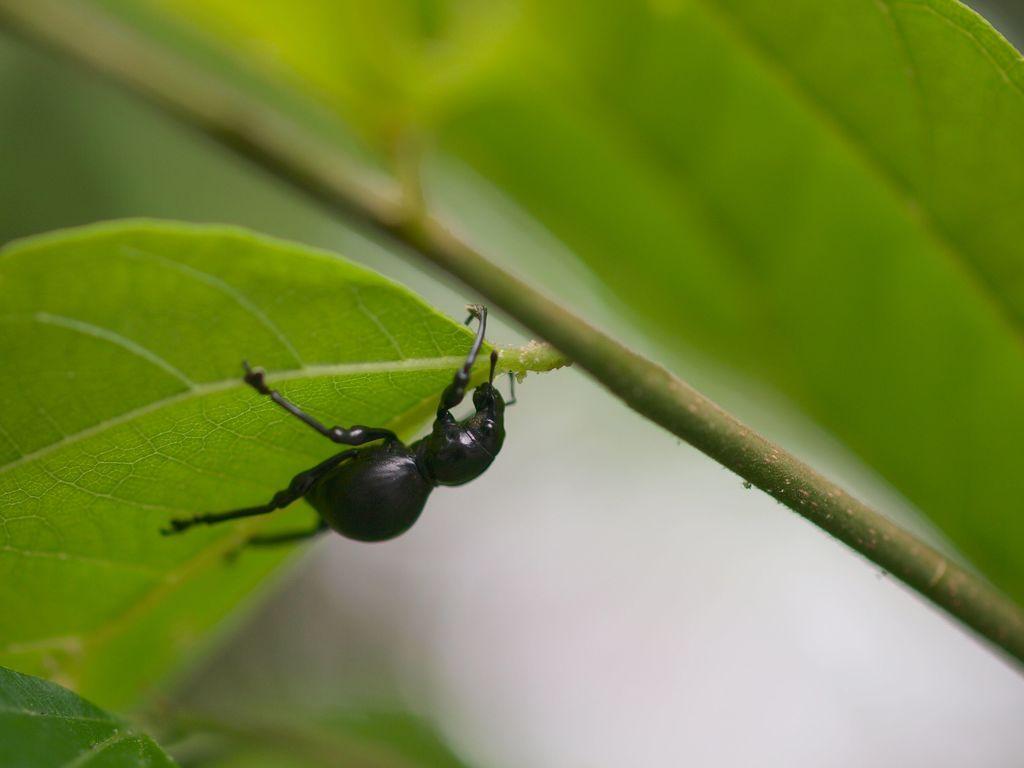Could you give a brief overview of what you see in this image? In the foreground of this image, there is a black insect on a leaf. At the top, there is another leaf to a stem. 